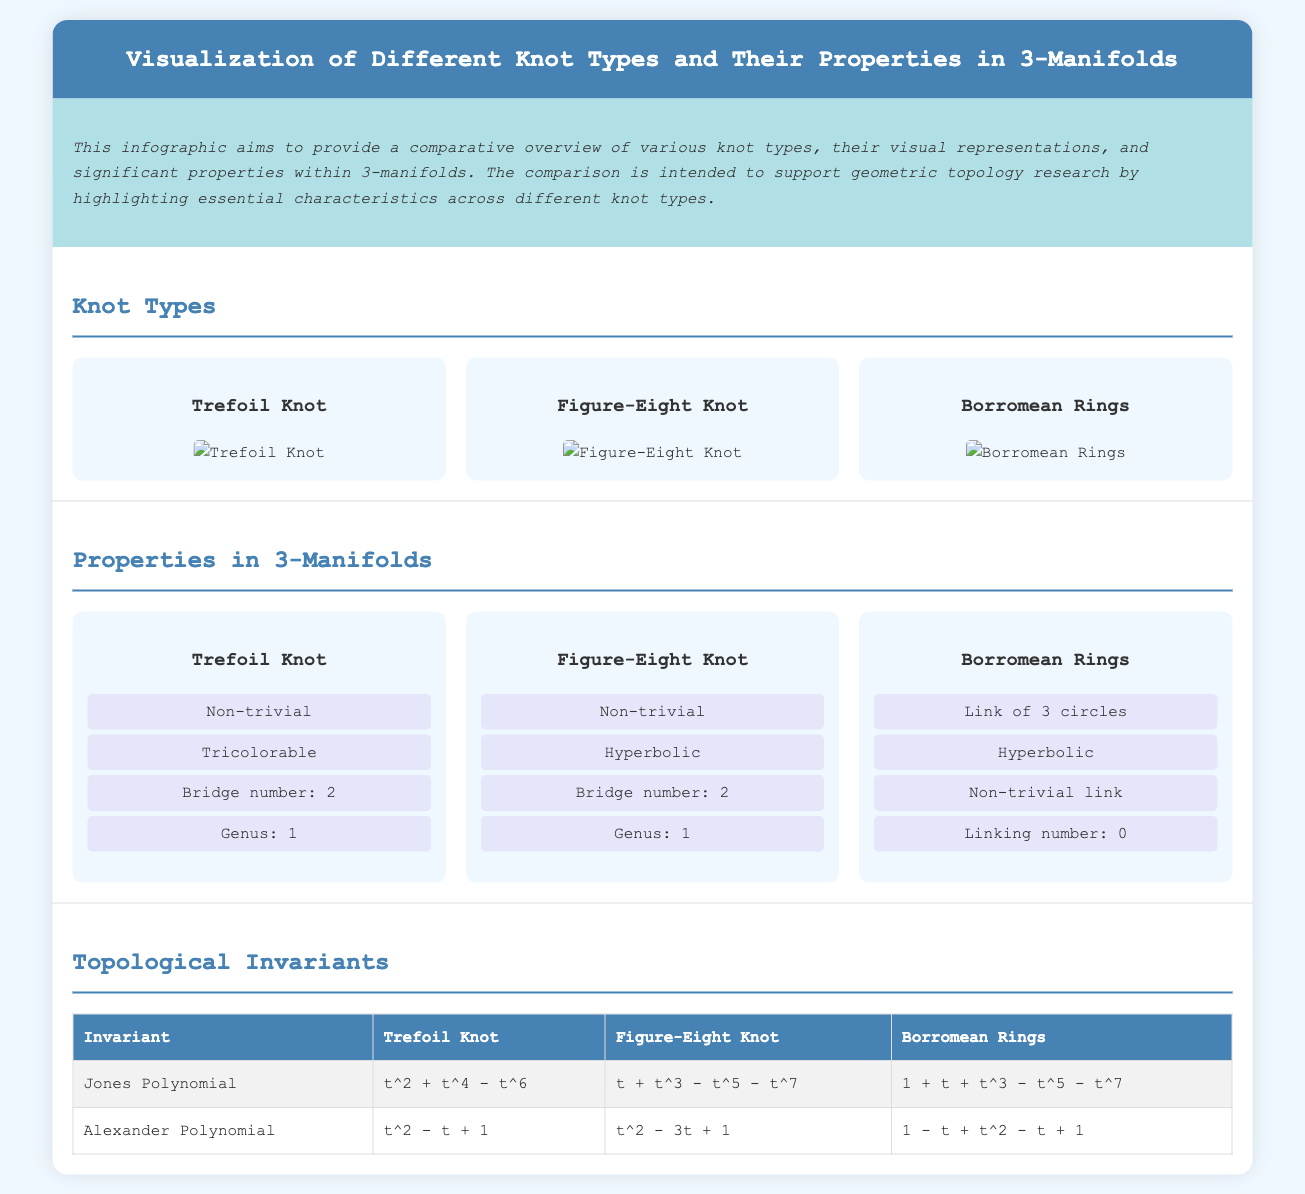What is the title of the infographic? The title is presented prominently at the top of the document.
Answer: Visualization of Different Knot Types and Their Properties in 3-Manifolds How many knot types are visualized? The number of knot types is indicated by the sections presented in the infographic.
Answer: 3 What is the bridge number of the Figure-Eight Knot? The bridge number is listed under the properties specific to the Figure-Eight Knot.
Answer: 2 What knot type is hyperbolic? The properties section specifies which knots are hyperbolic.
Answer: Figure-Eight Knot, Borromean Rings What is the Jones Polynomial for the Trefoil Knot? The Jones Polynomial is listed in the table of topological invariants.
Answer: t squared + t to the fourth - t to the sixth Which knot is tricolorable? This property is found in the list of characteristics for a specific knot type.
Answer: Trefoil Knot What is the linking number of the Borromean Rings? The linking number is mentioned within the properties section of the Borromean Rings.
Answer: 0 What genus does the Trefoil Knot have? The genus is a property listed in the properties section for the Trefoil Knot.
Answer: 1 What type of document is this? The layout and content indicate the nature of this document.
Answer: Comparison infographic 